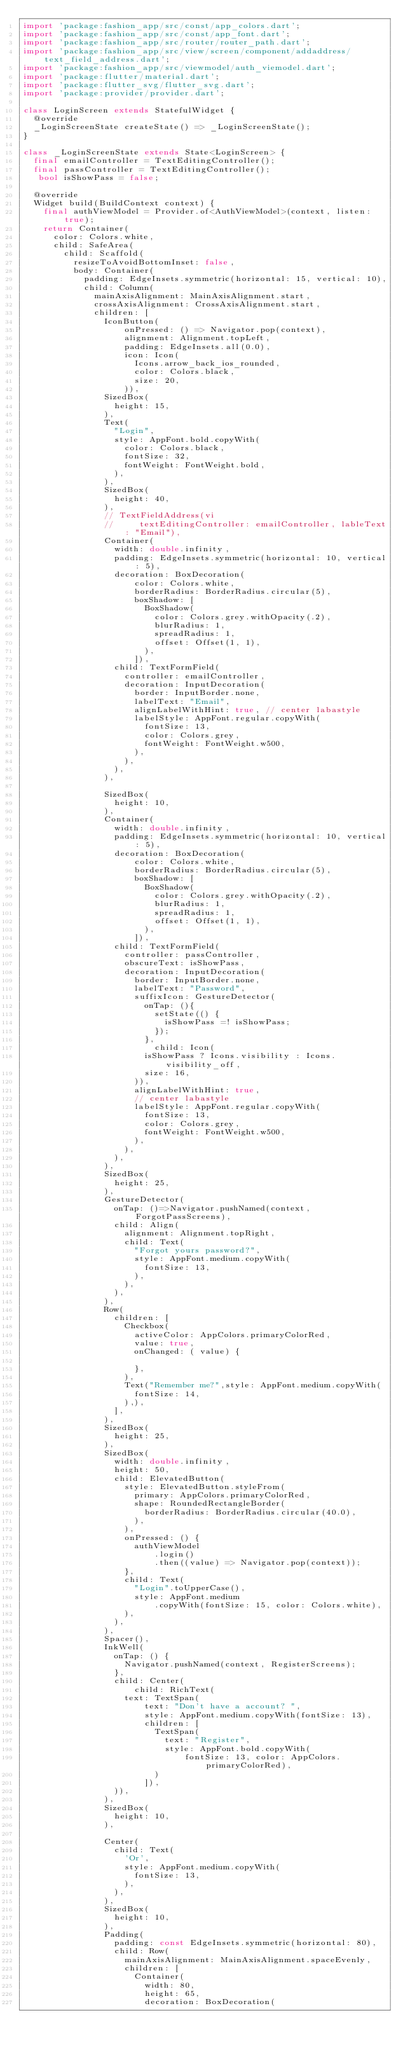Convert code to text. <code><loc_0><loc_0><loc_500><loc_500><_Dart_>import 'package:fashion_app/src/const/app_colors.dart';
import 'package:fashion_app/src/const/app_font.dart';
import 'package:fashion_app/src/router/router_path.dart';
import 'package:fashion_app/src/view/screen/component/addaddress/text_field_address.dart';
import 'package:fashion_app/src/viewmodel/auth_viemodel.dart';
import 'package:flutter/material.dart';
import 'package:flutter_svg/flutter_svg.dart';
import 'package:provider/provider.dart';

class LoginScreen extends StatefulWidget {
  @override
  _LoginScreenState createState() => _LoginScreenState();
}

class _LoginScreenState extends State<LoginScreen> {
  final emailController = TextEditingController();
  final passController = TextEditingController();
   bool isShowPass = false;

  @override
  Widget build(BuildContext context) {
    final authViewModel = Provider.of<AuthViewModel>(context, listen: true);
    return Container(
      color: Colors.white,
      child: SafeArea(
        child: Scaffold(
          resizeToAvoidBottomInset: false,
          body: Container(
            padding: EdgeInsets.symmetric(horizontal: 15, vertical: 10),
            child: Column(
              mainAxisAlignment: MainAxisAlignment.start,
              crossAxisAlignment: CrossAxisAlignment.start,
              children: [
                IconButton(
                    onPressed: () => Navigator.pop(context),
                    alignment: Alignment.topLeft,
                    padding: EdgeInsets.all(0.0),
                    icon: Icon(
                      Icons.arrow_back_ios_rounded,
                      color: Colors.black,
                      size: 20,
                    )),
                SizedBox(
                  height: 15,
                ),
                Text(
                  "Login",
                  style: AppFont.bold.copyWith(
                    color: Colors.black,
                    fontSize: 32,
                    fontWeight: FontWeight.bold,
                  ),
                ),
                SizedBox(
                  height: 40,
                ),
                // TextFieldAddress(vi
                //     textEditingController: emailController, lableText: "Email"),
                Container(
                  width: double.infinity,
                  padding: EdgeInsets.symmetric(horizontal: 10, vertical: 5),
                  decoration: BoxDecoration(
                      color: Colors.white,
                      borderRadius: BorderRadius.circular(5),
                      boxShadow: [
                        BoxShadow(
                          color: Colors.grey.withOpacity(.2),
                          blurRadius: 1,
                          spreadRadius: 1,
                          offset: Offset(1, 1),
                        ),
                      ]),
                  child: TextFormField(
                    controller: emailController,
                    decoration: InputDecoration(
                      border: InputBorder.none,
                      labelText: "Email",
                      alignLabelWithHint: true, // center labastyle
                      labelStyle: AppFont.regular.copyWith(
                        fontSize: 13,
                        color: Colors.grey,
                        fontWeight: FontWeight.w500,
                      ),
                    ),
                  ),
                ),

                SizedBox(
                  height: 10,
                ),
                Container(
                  width: double.infinity,
                  padding: EdgeInsets.symmetric(horizontal: 10, vertical: 5),
                  decoration: BoxDecoration(
                      color: Colors.white,
                      borderRadius: BorderRadius.circular(5),
                      boxShadow: [
                        BoxShadow(
                          color: Colors.grey.withOpacity(.2),
                          blurRadius: 1,
                          spreadRadius: 1,
                          offset: Offset(1, 1),
                        ),
                      ]),
                  child: TextFormField(
                    controller: passController,
                    obscureText: isShowPass,
                    decoration: InputDecoration(
                      border: InputBorder.none,
                      labelText: "Password",
                      suffixIcon: GestureDetector(
                        onTap: (){
                          setState(() {
                            isShowPass =! isShowPass;
                          });
                        },
                          child: Icon(
                        isShowPass ? Icons.visibility : Icons.visibility_off,
                        size: 16,
                      )),
                      alignLabelWithHint: true,
                      // center labastyle
                      labelStyle: AppFont.regular.copyWith(
                        fontSize: 13,
                        color: Colors.grey,
                        fontWeight: FontWeight.w500,
                      ),
                    ),
                  ),
                ),
                SizedBox(
                  height: 25,
                ),
                GestureDetector(
                  onTap: ()=>Navigator.pushNamed(context, ForgotPassScreens),
                  child: Align(
                    alignment: Alignment.topRight,
                    child: Text(
                      "Forgot yours password?",
                      style: AppFont.medium.copyWith(
                        fontSize: 13,
                      ),
                    ),
                  ),
                ),
                Row(
                  children: [
                    Checkbox(
                      activeColor: AppColors.primaryColorRed,
                      value: true,
                      onChanged: ( value) {

                      },
                    ),
                    Text("Remember me?",style: AppFont.medium.copyWith(
                      fontSize: 14,
                    ),),
                  ],
                ),
                SizedBox(
                  height: 25,
                ),
                SizedBox(
                  width: double.infinity,
                  height: 50,
                  child: ElevatedButton(
                    style: ElevatedButton.styleFrom(
                      primary: AppColors.primaryColorRed,
                      shape: RoundedRectangleBorder(
                        borderRadius: BorderRadius.circular(40.0),
                      ),
                    ),
                    onPressed: () {
                      authViewModel
                          .login()
                          .then((value) => Navigator.pop(context));
                    },
                    child: Text(
                      "Login".toUpperCase(),
                      style: AppFont.medium
                          .copyWith(fontSize: 15, color: Colors.white),
                    ),
                  ),
                ),
                Spacer(),
                InkWell(
                  onTap: () {
                    Navigator.pushNamed(context, RegisterScreens);
                  },
                  child: Center(
                      child: RichText(
                    text: TextSpan(
                        text: "Don't have a account? ",
                        style: AppFont.medium.copyWith(fontSize: 13),
                        children: [
                          TextSpan(
                            text: "Register",
                            style: AppFont.bold.copyWith(
                                fontSize: 13, color: AppColors.primaryColorRed),
                          )
                        ]),
                  )),
                ),
                SizedBox(
                  height: 10,
                ),

                Center(
                  child: Text(
                    'Or',
                    style: AppFont.medium.copyWith(
                      fontSize: 13,
                    ),
                  ),
                ),
                SizedBox(
                  height: 10,
                ),
                Padding(
                  padding: const EdgeInsets.symmetric(horizontal: 80),
                  child: Row(
                    mainAxisAlignment: MainAxisAlignment.spaceEvenly,
                    children: [
                      Container(
                        width: 80,
                        height: 65,
                        decoration: BoxDecoration(</code> 